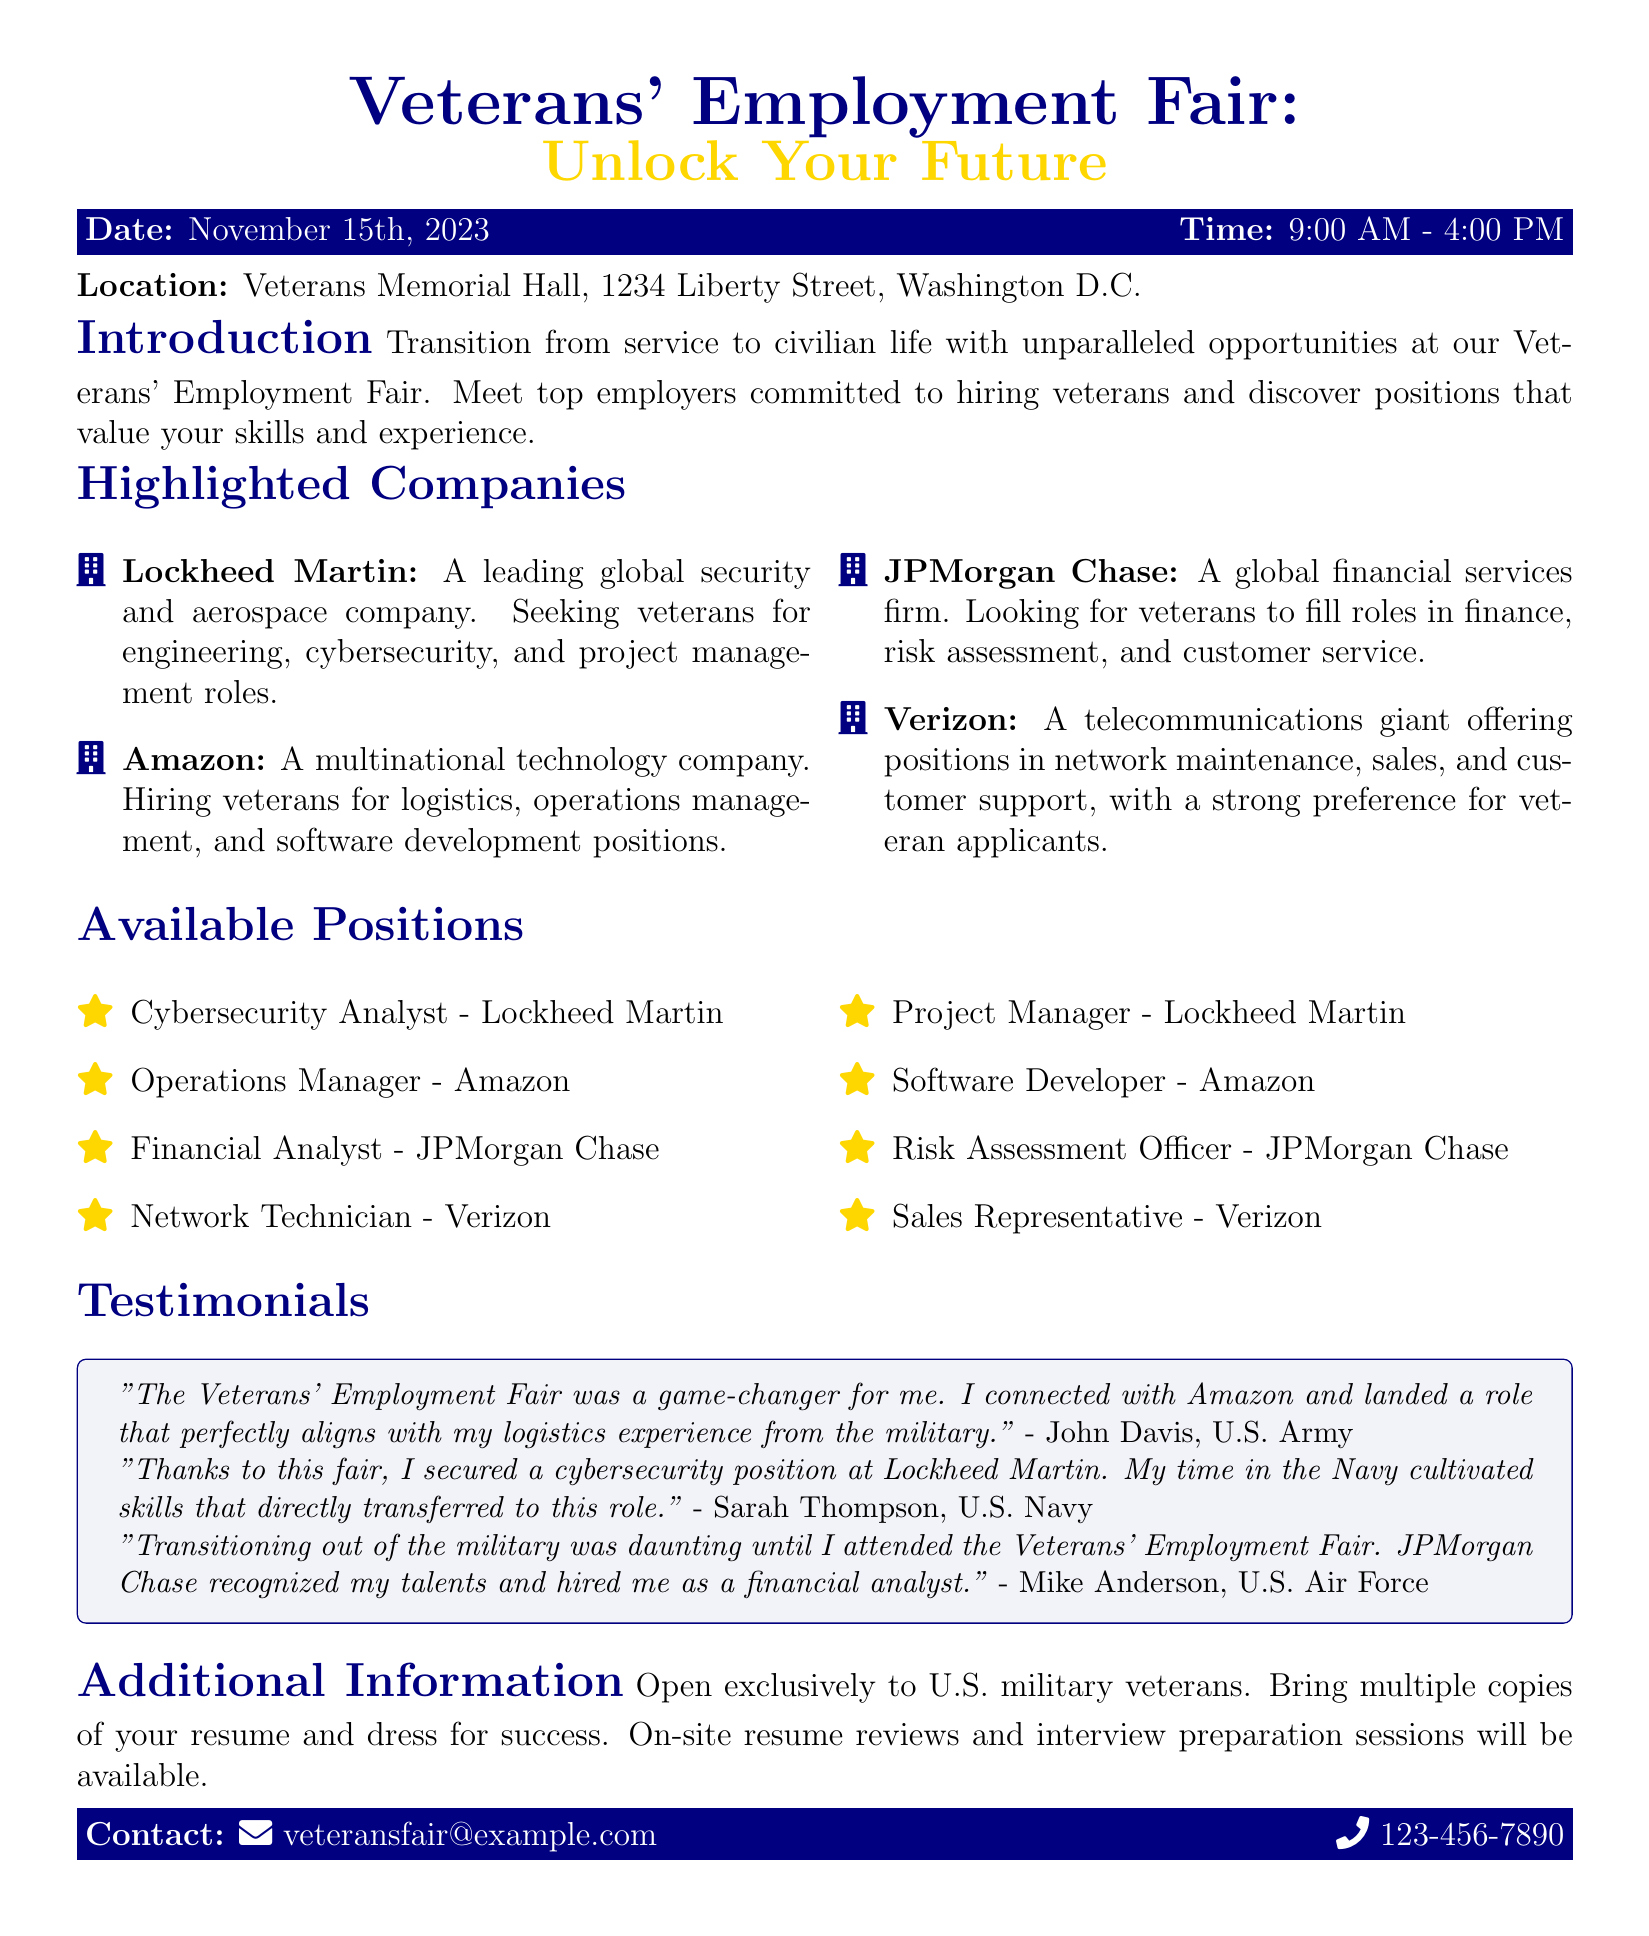What is the date of the Veterans' Employment Fair? The date of the event is mentioned explicitly in the document.
Answer: November 15th, 2023 What time does the fair start? The starting time is specified in the document along with the end time.
Answer: 9:00 AM Which company is seeking veterans for cybersecurity roles? This information can be retrieved from the highlighted companies section in the document.
Answer: Lockheed Martin What position is available at Verizon? The document lists specific available positions under Verizon.
Answer: Network Technician Who expressed gratitude for securing a cybersecurity position? This can be found in the testimonials section where veterans share their experiences.
Answer: Sarah Thompson What type of employment opportunities is the fair offering? The document states the nature of positions available for veterans.
Answer: Unparalleled opportunities Which company offers logistics positions? The highlighted companies section provides information about available roles by company.
Answer: Amazon Is the fair open to non-military individuals? The document specifies the eligibility criteria for attendees.
Answer: No What should veterans bring to the fair? This information is also mentioned in the additional information section of the document.
Answer: Multiple copies of your resume 